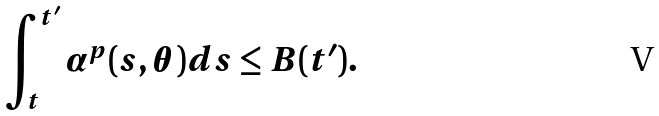Convert formula to latex. <formula><loc_0><loc_0><loc_500><loc_500>\int ^ { t ^ { \prime } } _ { t } \alpha ^ { p } ( s , \theta ) d s \leq B ( t ^ { \prime } ) .</formula> 